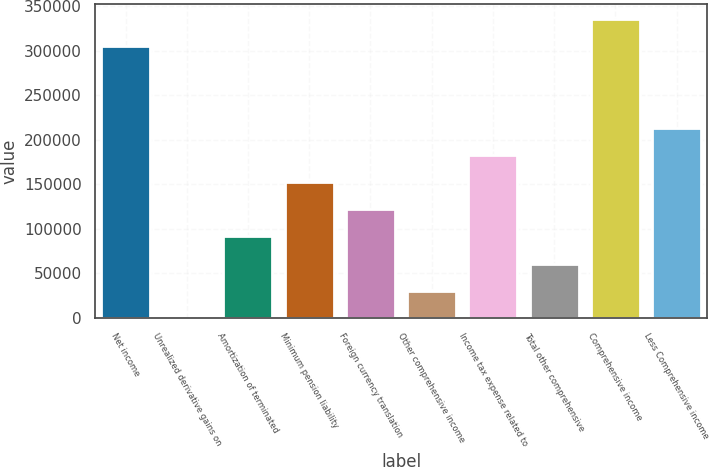Convert chart. <chart><loc_0><loc_0><loc_500><loc_500><bar_chart><fcel>Net income<fcel>Unrealized derivative gains on<fcel>Amortization of terminated<fcel>Minimum pension liability<fcel>Foreign currency translation<fcel>Other comprehensive income<fcel>Income tax expense related to<fcel>Total other comprehensive<fcel>Comprehensive income<fcel>Less Comprehensive income<nl><fcel>304995<fcel>0.29<fcel>91498.7<fcel>152498<fcel>121998<fcel>30499.8<fcel>182997<fcel>60999.2<fcel>335494<fcel>213497<nl></chart> 